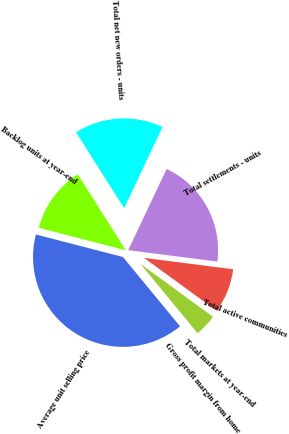<chart> <loc_0><loc_0><loc_500><loc_500><pie_chart><fcel>Total markets at year-end<fcel>Total active communities<fcel>Total settlements - units<fcel>Total net new orders - units<fcel>Backlog units at year-end<fcel>Average unit selling price<fcel>Gross profit margin from home<nl><fcel>4.0%<fcel>8.0%<fcel>20.0%<fcel>16.0%<fcel>12.0%<fcel>40.0%<fcel>0.0%<nl></chart> 